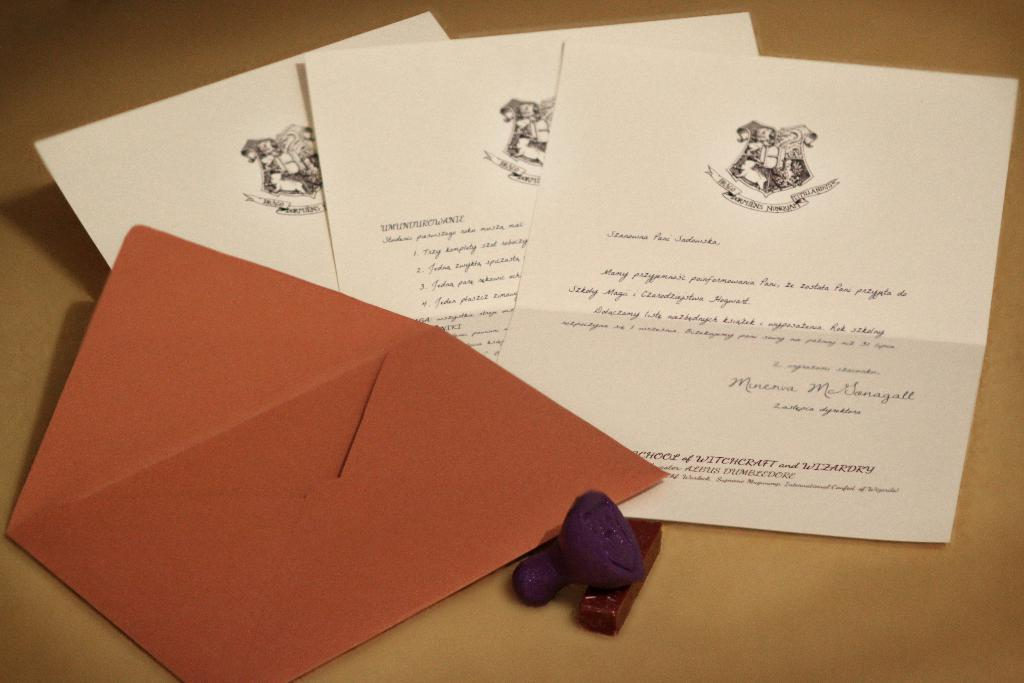How many papers are visible in the image? There are three papers in the image. What can be found on the papers? The papers have text and images on them. What else is present in the image besides the papers? There is an envelope cover and a rubber stamp in the image. What is the color of the surface in the image? The surface in the image is brown colored. Can you see the ocean in the image? No, the ocean is not present in the image. What type of system is being used to organize the papers in the image? There is no specific system mentioned or visible in the image for organizing the papers. 